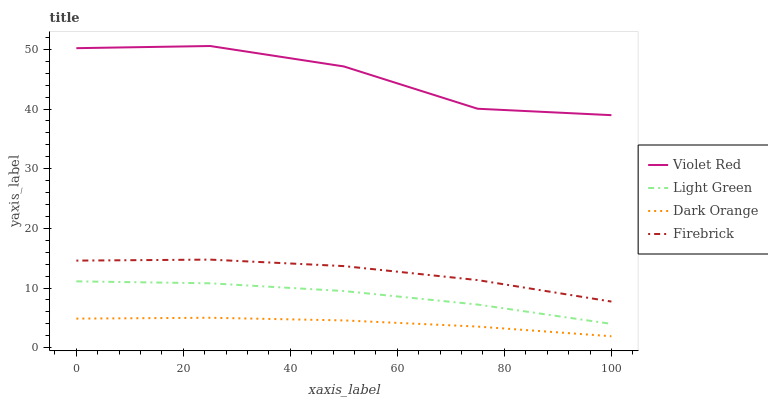Does Firebrick have the minimum area under the curve?
Answer yes or no. No. Does Firebrick have the maximum area under the curve?
Answer yes or no. No. Is Firebrick the smoothest?
Answer yes or no. No. Is Firebrick the roughest?
Answer yes or no. No. Does Firebrick have the lowest value?
Answer yes or no. No. Does Firebrick have the highest value?
Answer yes or no. No. Is Light Green less than Violet Red?
Answer yes or no. Yes. Is Violet Red greater than Firebrick?
Answer yes or no. Yes. Does Light Green intersect Violet Red?
Answer yes or no. No. 